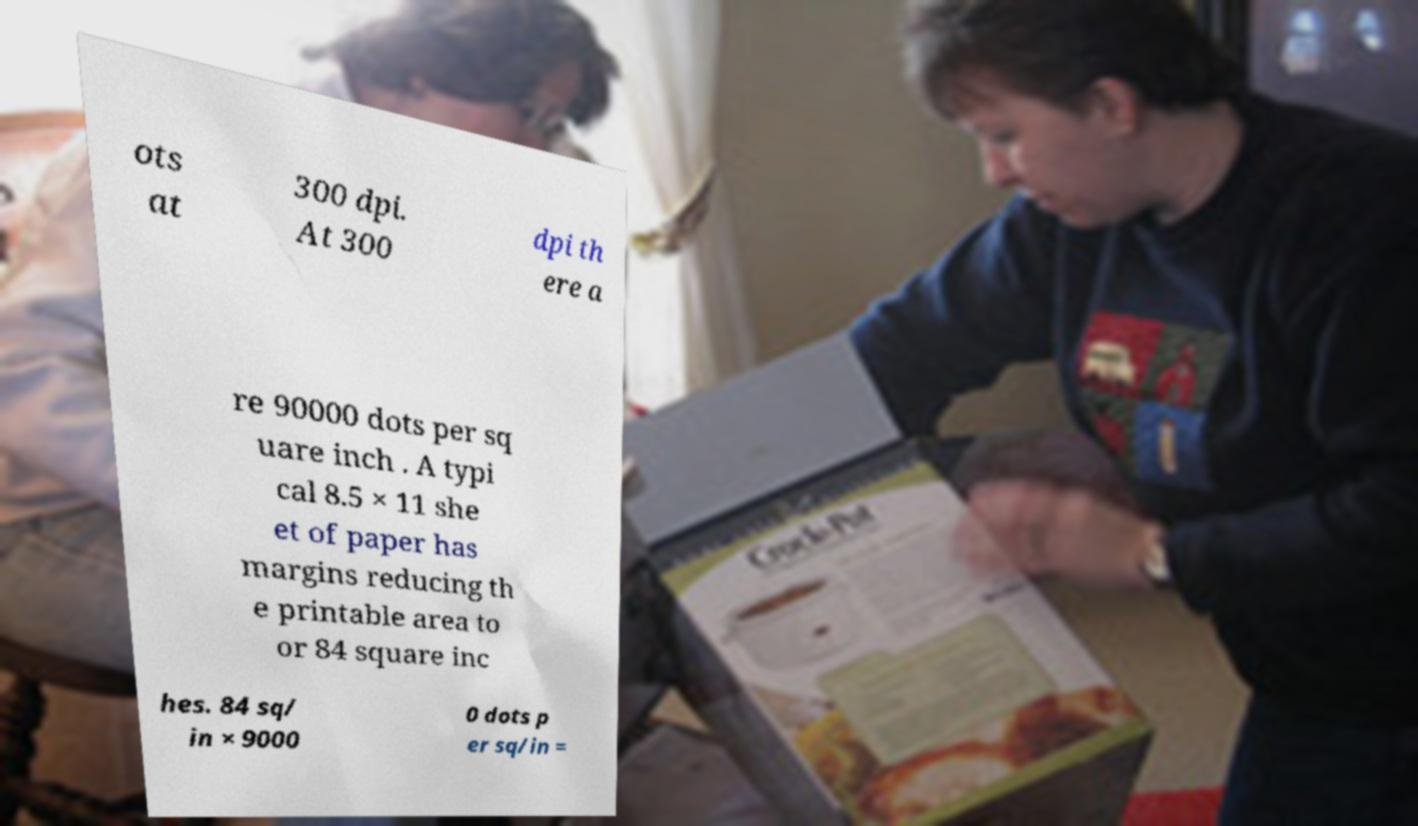Can you accurately transcribe the text from the provided image for me? ots at 300 dpi. At 300 dpi th ere a re 90000 dots per sq uare inch . A typi cal 8.5 × 11 she et of paper has margins reducing th e printable area to or 84 square inc hes. 84 sq/ in × 9000 0 dots p er sq/in = 